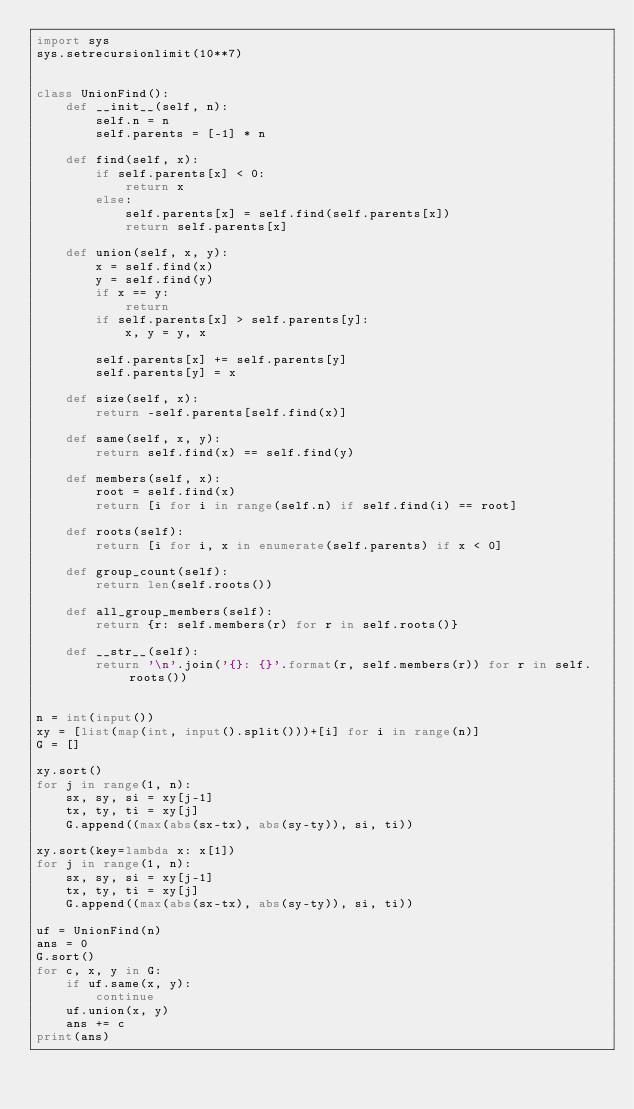<code> <loc_0><loc_0><loc_500><loc_500><_Python_>import sys
sys.setrecursionlimit(10**7)


class UnionFind():
    def __init__(self, n):
        self.n = n
        self.parents = [-1] * n

    def find(self, x):
        if self.parents[x] < 0:
            return x
        else:
            self.parents[x] = self.find(self.parents[x])
            return self.parents[x]

    def union(self, x, y):
        x = self.find(x)
        y = self.find(y)
        if x == y:
            return
        if self.parents[x] > self.parents[y]:
            x, y = y, x

        self.parents[x] += self.parents[y]
        self.parents[y] = x

    def size(self, x):
        return -self.parents[self.find(x)]

    def same(self, x, y):
        return self.find(x) == self.find(y)

    def members(self, x):
        root = self.find(x)
        return [i for i in range(self.n) if self.find(i) == root]

    def roots(self):
        return [i for i, x in enumerate(self.parents) if x < 0]

    def group_count(self):
        return len(self.roots())

    def all_group_members(self):
        return {r: self.members(r) for r in self.roots()}

    def __str__(self):
        return '\n'.join('{}: {}'.format(r, self.members(r)) for r in self.roots())


n = int(input())
xy = [list(map(int, input().split()))+[i] for i in range(n)]
G = []

xy.sort()
for j in range(1, n):
    sx, sy, si = xy[j-1]
    tx, ty, ti = xy[j]
    G.append((max(abs(sx-tx), abs(sy-ty)), si, ti))

xy.sort(key=lambda x: x[1])
for j in range(1, n):
    sx, sy, si = xy[j-1]
    tx, ty, ti = xy[j]
    G.append((max(abs(sx-tx), abs(sy-ty)), si, ti))

uf = UnionFind(n)
ans = 0
G.sort()
for c, x, y in G:
    if uf.same(x, y):
        continue
    uf.union(x, y)
    ans += c
print(ans)
</code> 